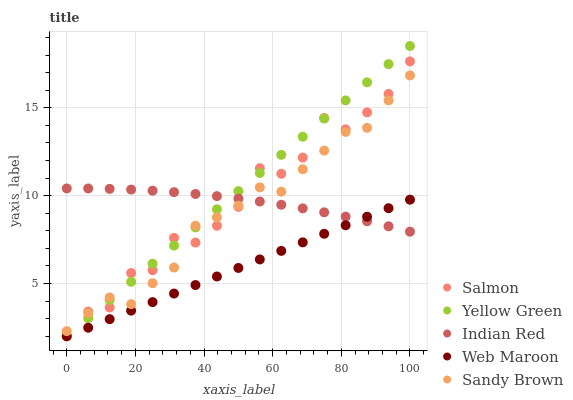Does Web Maroon have the minimum area under the curve?
Answer yes or no. Yes. Does Yellow Green have the maximum area under the curve?
Answer yes or no. Yes. Does Salmon have the minimum area under the curve?
Answer yes or no. No. Does Salmon have the maximum area under the curve?
Answer yes or no. No. Is Web Maroon the smoothest?
Answer yes or no. Yes. Is Salmon the roughest?
Answer yes or no. Yes. Is Salmon the smoothest?
Answer yes or no. No. Is Web Maroon the roughest?
Answer yes or no. No. Does Web Maroon have the lowest value?
Answer yes or no. Yes. Does Indian Red have the lowest value?
Answer yes or no. No. Does Yellow Green have the highest value?
Answer yes or no. Yes. Does Salmon have the highest value?
Answer yes or no. No. Is Web Maroon less than Sandy Brown?
Answer yes or no. Yes. Is Sandy Brown greater than Web Maroon?
Answer yes or no. Yes. Does Salmon intersect Sandy Brown?
Answer yes or no. Yes. Is Salmon less than Sandy Brown?
Answer yes or no. No. Is Salmon greater than Sandy Brown?
Answer yes or no. No. Does Web Maroon intersect Sandy Brown?
Answer yes or no. No. 